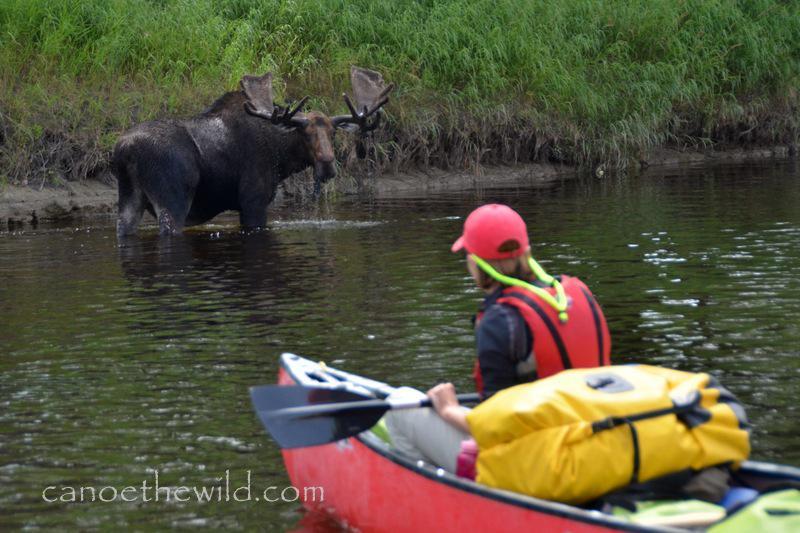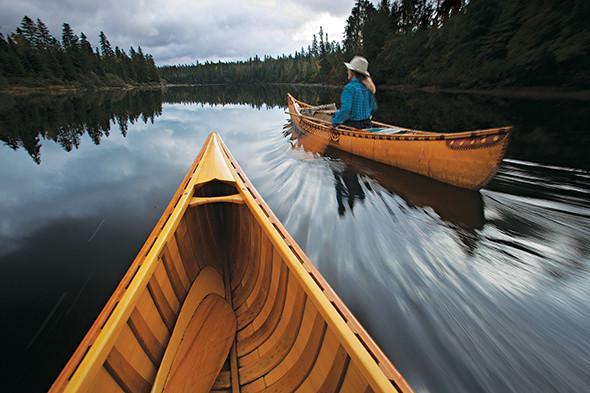The first image is the image on the left, the second image is the image on the right. For the images displayed, is the sentence "A boat is floating in water." factually correct? Answer yes or no. Yes. The first image is the image on the left, the second image is the image on the right. Evaluate the accuracy of this statement regarding the images: "There are not human beings visible in at least one image.". Is it true? Answer yes or no. No. 